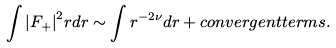Convert formula to latex. <formula><loc_0><loc_0><loc_500><loc_500>\int { | F _ { + } | } ^ { 2 } r d r \sim \int r ^ { - 2 \nu } d r + c o n v e r g e n t t e r m s .</formula> 